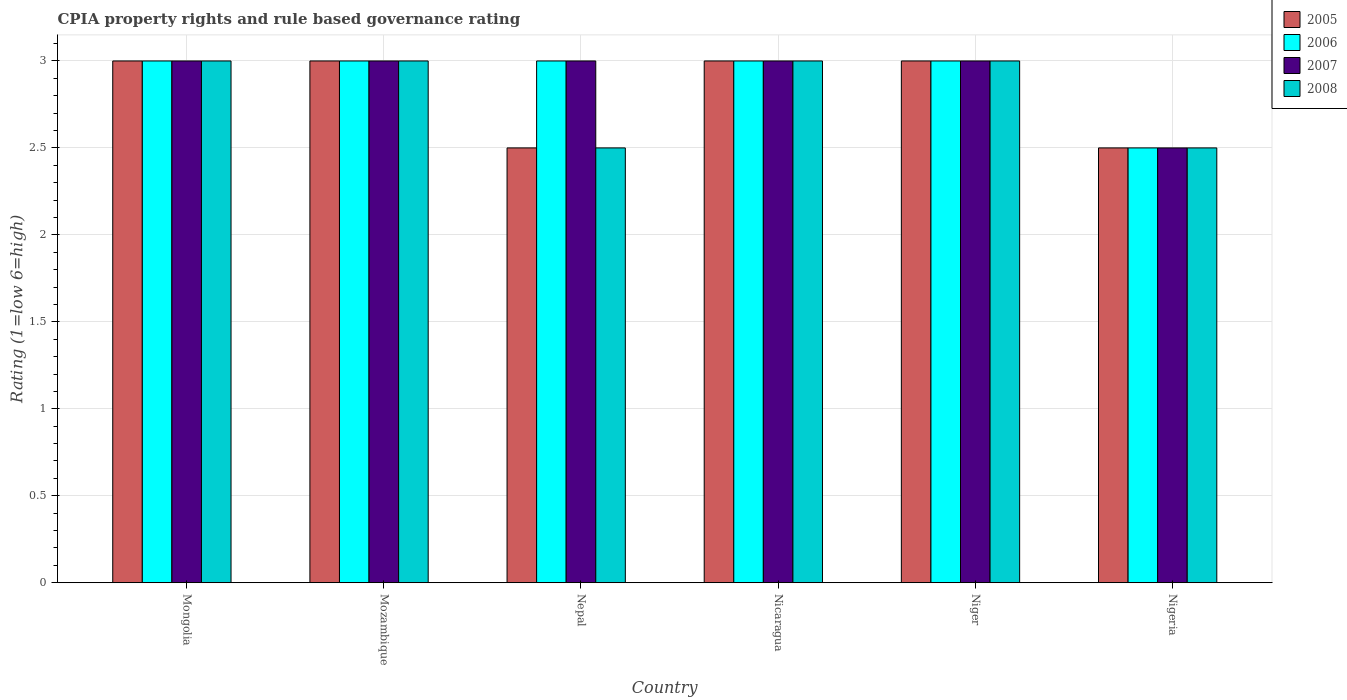How many groups of bars are there?
Your answer should be very brief. 6. Are the number of bars on each tick of the X-axis equal?
Make the answer very short. Yes. How many bars are there on the 1st tick from the left?
Make the answer very short. 4. How many bars are there on the 5th tick from the right?
Give a very brief answer. 4. What is the label of the 5th group of bars from the left?
Ensure brevity in your answer.  Niger. What is the CPIA rating in 2005 in Nepal?
Keep it short and to the point. 2.5. In which country was the CPIA rating in 2005 maximum?
Offer a terse response. Mongolia. In which country was the CPIA rating in 2007 minimum?
Provide a short and direct response. Nigeria. What is the difference between the CPIA rating in 2008 in Mongolia and that in Mozambique?
Give a very brief answer. 0. What is the average CPIA rating in 2006 per country?
Offer a terse response. 2.92. What is the difference between the CPIA rating of/in 2005 and CPIA rating of/in 2006 in Nicaragua?
Your response must be concise. 0. What is the ratio of the CPIA rating in 2006 in Mozambique to that in Nepal?
Offer a very short reply. 1. Is the difference between the CPIA rating in 2005 in Mozambique and Niger greater than the difference between the CPIA rating in 2006 in Mozambique and Niger?
Give a very brief answer. No. In how many countries, is the CPIA rating in 2005 greater than the average CPIA rating in 2005 taken over all countries?
Your response must be concise. 4. Is the sum of the CPIA rating in 2007 in Mongolia and Nigeria greater than the maximum CPIA rating in 2005 across all countries?
Offer a very short reply. Yes. Is it the case that in every country, the sum of the CPIA rating in 2005 and CPIA rating in 2006 is greater than the sum of CPIA rating in 2008 and CPIA rating in 2007?
Provide a succinct answer. No. What does the 1st bar from the left in Nigeria represents?
Offer a terse response. 2005. What does the 1st bar from the right in Mozambique represents?
Offer a very short reply. 2008. Is it the case that in every country, the sum of the CPIA rating in 2007 and CPIA rating in 2006 is greater than the CPIA rating in 2005?
Offer a very short reply. Yes. Does the graph contain any zero values?
Your answer should be very brief. No. Does the graph contain grids?
Keep it short and to the point. Yes. How many legend labels are there?
Provide a succinct answer. 4. How are the legend labels stacked?
Make the answer very short. Vertical. What is the title of the graph?
Your answer should be compact. CPIA property rights and rule based governance rating. Does "1993" appear as one of the legend labels in the graph?
Your response must be concise. No. What is the Rating (1=low 6=high) of 2005 in Mongolia?
Give a very brief answer. 3. What is the Rating (1=low 6=high) in 2008 in Mongolia?
Provide a succinct answer. 3. What is the Rating (1=low 6=high) of 2006 in Nepal?
Make the answer very short. 3. What is the Rating (1=low 6=high) in 2008 in Nepal?
Make the answer very short. 2.5. What is the Rating (1=low 6=high) of 2005 in Nicaragua?
Offer a very short reply. 3. What is the Rating (1=low 6=high) in 2006 in Nicaragua?
Provide a short and direct response. 3. What is the Rating (1=low 6=high) of 2007 in Nicaragua?
Your answer should be very brief. 3. What is the Rating (1=low 6=high) of 2005 in Niger?
Your response must be concise. 3. What is the Rating (1=low 6=high) in 2007 in Niger?
Provide a succinct answer. 3. What is the Rating (1=low 6=high) in 2005 in Nigeria?
Provide a succinct answer. 2.5. What is the Rating (1=low 6=high) of 2006 in Nigeria?
Your response must be concise. 2.5. What is the Rating (1=low 6=high) in 2007 in Nigeria?
Offer a terse response. 2.5. What is the Rating (1=low 6=high) of 2008 in Nigeria?
Your answer should be compact. 2.5. Across all countries, what is the maximum Rating (1=low 6=high) of 2005?
Your answer should be compact. 3. Across all countries, what is the minimum Rating (1=low 6=high) of 2005?
Make the answer very short. 2.5. What is the difference between the Rating (1=low 6=high) in 2005 in Mongolia and that in Mozambique?
Give a very brief answer. 0. What is the difference between the Rating (1=low 6=high) in 2006 in Mongolia and that in Mozambique?
Offer a very short reply. 0. What is the difference between the Rating (1=low 6=high) in 2007 in Mongolia and that in Mozambique?
Ensure brevity in your answer.  0. What is the difference between the Rating (1=low 6=high) of 2006 in Mongolia and that in Nepal?
Your answer should be compact. 0. What is the difference between the Rating (1=low 6=high) in 2007 in Mongolia and that in Nepal?
Offer a terse response. 0. What is the difference between the Rating (1=low 6=high) in 2008 in Mongolia and that in Nepal?
Your response must be concise. 0.5. What is the difference between the Rating (1=low 6=high) of 2005 in Mongolia and that in Nicaragua?
Provide a short and direct response. 0. What is the difference between the Rating (1=low 6=high) of 2006 in Mongolia and that in Nicaragua?
Your answer should be compact. 0. What is the difference between the Rating (1=low 6=high) of 2008 in Mongolia and that in Nicaragua?
Your answer should be compact. 0. What is the difference between the Rating (1=low 6=high) of 2006 in Mongolia and that in Niger?
Offer a very short reply. 0. What is the difference between the Rating (1=low 6=high) of 2007 in Mongolia and that in Niger?
Provide a short and direct response. 0. What is the difference between the Rating (1=low 6=high) in 2008 in Mongolia and that in Niger?
Keep it short and to the point. 0. What is the difference between the Rating (1=low 6=high) of 2006 in Mongolia and that in Nigeria?
Your answer should be very brief. 0.5. What is the difference between the Rating (1=low 6=high) in 2007 in Mongolia and that in Nigeria?
Make the answer very short. 0.5. What is the difference between the Rating (1=low 6=high) in 2008 in Mongolia and that in Nigeria?
Keep it short and to the point. 0.5. What is the difference between the Rating (1=low 6=high) in 2006 in Mozambique and that in Nepal?
Give a very brief answer. 0. What is the difference between the Rating (1=low 6=high) of 2007 in Mozambique and that in Nepal?
Offer a terse response. 0. What is the difference between the Rating (1=low 6=high) in 2008 in Mozambique and that in Nepal?
Ensure brevity in your answer.  0.5. What is the difference between the Rating (1=low 6=high) in 2007 in Mozambique and that in Nicaragua?
Offer a very short reply. 0. What is the difference between the Rating (1=low 6=high) of 2007 in Mozambique and that in Niger?
Provide a succinct answer. 0. What is the difference between the Rating (1=low 6=high) in 2006 in Mozambique and that in Nigeria?
Ensure brevity in your answer.  0.5. What is the difference between the Rating (1=low 6=high) in 2007 in Mozambique and that in Nigeria?
Offer a very short reply. 0.5. What is the difference between the Rating (1=low 6=high) in 2008 in Mozambique and that in Nigeria?
Give a very brief answer. 0.5. What is the difference between the Rating (1=low 6=high) in 2007 in Nepal and that in Nicaragua?
Keep it short and to the point. 0. What is the difference between the Rating (1=low 6=high) in 2006 in Nepal and that in Nigeria?
Give a very brief answer. 0.5. What is the difference between the Rating (1=low 6=high) of 2008 in Nepal and that in Nigeria?
Ensure brevity in your answer.  0. What is the difference between the Rating (1=low 6=high) of 2005 in Nicaragua and that in Nigeria?
Make the answer very short. 0.5. What is the difference between the Rating (1=low 6=high) in 2006 in Nicaragua and that in Nigeria?
Your answer should be very brief. 0.5. What is the difference between the Rating (1=low 6=high) of 2008 in Nicaragua and that in Nigeria?
Your answer should be compact. 0.5. What is the difference between the Rating (1=low 6=high) of 2005 in Niger and that in Nigeria?
Offer a very short reply. 0.5. What is the difference between the Rating (1=low 6=high) in 2006 in Niger and that in Nigeria?
Your answer should be very brief. 0.5. What is the difference between the Rating (1=low 6=high) in 2008 in Niger and that in Nigeria?
Offer a very short reply. 0.5. What is the difference between the Rating (1=low 6=high) in 2005 in Mongolia and the Rating (1=low 6=high) in 2006 in Mozambique?
Give a very brief answer. 0. What is the difference between the Rating (1=low 6=high) of 2005 in Mongolia and the Rating (1=low 6=high) of 2007 in Mozambique?
Provide a short and direct response. 0. What is the difference between the Rating (1=low 6=high) of 2005 in Mongolia and the Rating (1=low 6=high) of 2008 in Mozambique?
Your response must be concise. 0. What is the difference between the Rating (1=low 6=high) in 2006 in Mongolia and the Rating (1=low 6=high) in 2008 in Mozambique?
Your response must be concise. 0. What is the difference between the Rating (1=low 6=high) of 2007 in Mongolia and the Rating (1=low 6=high) of 2008 in Mozambique?
Your response must be concise. 0. What is the difference between the Rating (1=low 6=high) of 2005 in Mongolia and the Rating (1=low 6=high) of 2007 in Nepal?
Your response must be concise. 0. What is the difference between the Rating (1=low 6=high) of 2006 in Mongolia and the Rating (1=low 6=high) of 2008 in Nepal?
Provide a succinct answer. 0.5. What is the difference between the Rating (1=low 6=high) of 2005 in Mongolia and the Rating (1=low 6=high) of 2006 in Nicaragua?
Offer a very short reply. 0. What is the difference between the Rating (1=low 6=high) of 2005 in Mongolia and the Rating (1=low 6=high) of 2007 in Nicaragua?
Ensure brevity in your answer.  0. What is the difference between the Rating (1=low 6=high) of 2005 in Mongolia and the Rating (1=low 6=high) of 2008 in Nicaragua?
Your answer should be very brief. 0. What is the difference between the Rating (1=low 6=high) of 2006 in Mongolia and the Rating (1=low 6=high) of 2008 in Nicaragua?
Offer a very short reply. 0. What is the difference between the Rating (1=low 6=high) in 2005 in Mongolia and the Rating (1=low 6=high) in 2007 in Niger?
Give a very brief answer. 0. What is the difference between the Rating (1=low 6=high) of 2005 in Mongolia and the Rating (1=low 6=high) of 2008 in Niger?
Your answer should be compact. 0. What is the difference between the Rating (1=low 6=high) of 2006 in Mongolia and the Rating (1=low 6=high) of 2007 in Niger?
Give a very brief answer. 0. What is the difference between the Rating (1=low 6=high) in 2007 in Mongolia and the Rating (1=low 6=high) in 2008 in Niger?
Your answer should be very brief. 0. What is the difference between the Rating (1=low 6=high) of 2007 in Mozambique and the Rating (1=low 6=high) of 2008 in Nepal?
Make the answer very short. 0.5. What is the difference between the Rating (1=low 6=high) of 2005 in Mozambique and the Rating (1=low 6=high) of 2006 in Nicaragua?
Your answer should be compact. 0. What is the difference between the Rating (1=low 6=high) in 2005 in Mozambique and the Rating (1=low 6=high) in 2008 in Nicaragua?
Ensure brevity in your answer.  0. What is the difference between the Rating (1=low 6=high) of 2006 in Mozambique and the Rating (1=low 6=high) of 2007 in Nicaragua?
Keep it short and to the point. 0. What is the difference between the Rating (1=low 6=high) of 2007 in Mozambique and the Rating (1=low 6=high) of 2008 in Nicaragua?
Your answer should be compact. 0. What is the difference between the Rating (1=low 6=high) of 2006 in Mozambique and the Rating (1=low 6=high) of 2007 in Niger?
Give a very brief answer. 0. What is the difference between the Rating (1=low 6=high) in 2006 in Mozambique and the Rating (1=low 6=high) in 2008 in Niger?
Ensure brevity in your answer.  0. What is the difference between the Rating (1=low 6=high) of 2005 in Mozambique and the Rating (1=low 6=high) of 2007 in Nigeria?
Your response must be concise. 0.5. What is the difference between the Rating (1=low 6=high) in 2005 in Nepal and the Rating (1=low 6=high) in 2006 in Nicaragua?
Ensure brevity in your answer.  -0.5. What is the difference between the Rating (1=low 6=high) of 2005 in Nepal and the Rating (1=low 6=high) of 2007 in Nicaragua?
Ensure brevity in your answer.  -0.5. What is the difference between the Rating (1=low 6=high) in 2005 in Nepal and the Rating (1=low 6=high) in 2006 in Niger?
Your answer should be very brief. -0.5. What is the difference between the Rating (1=low 6=high) in 2006 in Nepal and the Rating (1=low 6=high) in 2007 in Niger?
Offer a terse response. 0. What is the difference between the Rating (1=low 6=high) in 2007 in Nepal and the Rating (1=low 6=high) in 2008 in Niger?
Give a very brief answer. 0. What is the difference between the Rating (1=low 6=high) of 2005 in Nepal and the Rating (1=low 6=high) of 2006 in Nigeria?
Give a very brief answer. 0. What is the difference between the Rating (1=low 6=high) of 2006 in Nepal and the Rating (1=low 6=high) of 2007 in Nigeria?
Make the answer very short. 0.5. What is the difference between the Rating (1=low 6=high) of 2007 in Nepal and the Rating (1=low 6=high) of 2008 in Nigeria?
Make the answer very short. 0.5. What is the difference between the Rating (1=low 6=high) of 2005 in Nicaragua and the Rating (1=low 6=high) of 2007 in Niger?
Your response must be concise. 0. What is the difference between the Rating (1=low 6=high) in 2006 in Nicaragua and the Rating (1=low 6=high) in 2008 in Niger?
Your answer should be compact. 0. What is the difference between the Rating (1=low 6=high) of 2005 in Nicaragua and the Rating (1=low 6=high) of 2007 in Nigeria?
Offer a terse response. 0.5. What is the difference between the Rating (1=low 6=high) of 2006 in Nicaragua and the Rating (1=low 6=high) of 2007 in Nigeria?
Offer a terse response. 0.5. What is the difference between the Rating (1=low 6=high) of 2007 in Nicaragua and the Rating (1=low 6=high) of 2008 in Nigeria?
Provide a short and direct response. 0.5. What is the difference between the Rating (1=low 6=high) in 2005 in Niger and the Rating (1=low 6=high) in 2006 in Nigeria?
Make the answer very short. 0.5. What is the difference between the Rating (1=low 6=high) of 2006 in Niger and the Rating (1=low 6=high) of 2007 in Nigeria?
Provide a short and direct response. 0.5. What is the difference between the Rating (1=low 6=high) in 2007 in Niger and the Rating (1=low 6=high) in 2008 in Nigeria?
Your response must be concise. 0.5. What is the average Rating (1=low 6=high) in 2005 per country?
Your response must be concise. 2.83. What is the average Rating (1=low 6=high) of 2006 per country?
Your answer should be compact. 2.92. What is the average Rating (1=low 6=high) of 2007 per country?
Your answer should be compact. 2.92. What is the average Rating (1=low 6=high) of 2008 per country?
Ensure brevity in your answer.  2.83. What is the difference between the Rating (1=low 6=high) in 2005 and Rating (1=low 6=high) in 2008 in Mongolia?
Provide a short and direct response. 0. What is the difference between the Rating (1=low 6=high) in 2006 and Rating (1=low 6=high) in 2008 in Mongolia?
Your response must be concise. 0. What is the difference between the Rating (1=low 6=high) of 2007 and Rating (1=low 6=high) of 2008 in Mongolia?
Offer a terse response. 0. What is the difference between the Rating (1=low 6=high) in 2005 and Rating (1=low 6=high) in 2007 in Mozambique?
Give a very brief answer. 0. What is the difference between the Rating (1=low 6=high) in 2005 and Rating (1=low 6=high) in 2008 in Mozambique?
Keep it short and to the point. 0. What is the difference between the Rating (1=low 6=high) of 2007 and Rating (1=low 6=high) of 2008 in Mozambique?
Provide a succinct answer. 0. What is the difference between the Rating (1=low 6=high) in 2005 and Rating (1=low 6=high) in 2006 in Nepal?
Make the answer very short. -0.5. What is the difference between the Rating (1=low 6=high) in 2005 and Rating (1=low 6=high) in 2007 in Nepal?
Make the answer very short. -0.5. What is the difference between the Rating (1=low 6=high) in 2005 and Rating (1=low 6=high) in 2007 in Nicaragua?
Keep it short and to the point. 0. What is the difference between the Rating (1=low 6=high) in 2005 and Rating (1=low 6=high) in 2008 in Nicaragua?
Your answer should be very brief. 0. What is the difference between the Rating (1=low 6=high) in 2007 and Rating (1=low 6=high) in 2008 in Nicaragua?
Keep it short and to the point. 0. What is the difference between the Rating (1=low 6=high) of 2005 and Rating (1=low 6=high) of 2006 in Niger?
Provide a succinct answer. 0. What is the difference between the Rating (1=low 6=high) in 2005 and Rating (1=low 6=high) in 2007 in Niger?
Provide a succinct answer. 0. What is the difference between the Rating (1=low 6=high) in 2005 and Rating (1=low 6=high) in 2008 in Niger?
Your answer should be very brief. 0. What is the difference between the Rating (1=low 6=high) in 2005 and Rating (1=low 6=high) in 2006 in Nigeria?
Offer a very short reply. 0. What is the difference between the Rating (1=low 6=high) in 2005 and Rating (1=low 6=high) in 2007 in Nigeria?
Offer a terse response. 0. What is the difference between the Rating (1=low 6=high) in 2005 and Rating (1=low 6=high) in 2008 in Nigeria?
Keep it short and to the point. 0. What is the difference between the Rating (1=low 6=high) in 2006 and Rating (1=low 6=high) in 2007 in Nigeria?
Offer a terse response. 0. What is the difference between the Rating (1=low 6=high) in 2007 and Rating (1=low 6=high) in 2008 in Nigeria?
Your response must be concise. 0. What is the ratio of the Rating (1=low 6=high) of 2006 in Mongolia to that in Mozambique?
Provide a short and direct response. 1. What is the ratio of the Rating (1=low 6=high) of 2008 in Mongolia to that in Mozambique?
Your answer should be compact. 1. What is the ratio of the Rating (1=low 6=high) of 2005 in Mongolia to that in Nepal?
Make the answer very short. 1.2. What is the ratio of the Rating (1=low 6=high) of 2006 in Mongolia to that in Nepal?
Keep it short and to the point. 1. What is the ratio of the Rating (1=low 6=high) of 2007 in Mongolia to that in Nepal?
Provide a succinct answer. 1. What is the ratio of the Rating (1=low 6=high) in 2008 in Mongolia to that in Nepal?
Your answer should be very brief. 1.2. What is the ratio of the Rating (1=low 6=high) of 2006 in Mongolia to that in Nicaragua?
Provide a short and direct response. 1. What is the ratio of the Rating (1=low 6=high) in 2008 in Mongolia to that in Nicaragua?
Provide a succinct answer. 1. What is the ratio of the Rating (1=low 6=high) of 2006 in Mongolia to that in Niger?
Your response must be concise. 1. What is the ratio of the Rating (1=low 6=high) in 2007 in Mongolia to that in Niger?
Your answer should be very brief. 1. What is the ratio of the Rating (1=low 6=high) of 2005 in Mongolia to that in Nigeria?
Your answer should be compact. 1.2. What is the ratio of the Rating (1=low 6=high) of 2006 in Mongolia to that in Nigeria?
Your answer should be very brief. 1.2. What is the ratio of the Rating (1=low 6=high) of 2008 in Mongolia to that in Nigeria?
Make the answer very short. 1.2. What is the ratio of the Rating (1=low 6=high) of 2005 in Mozambique to that in Nepal?
Give a very brief answer. 1.2. What is the ratio of the Rating (1=low 6=high) of 2006 in Mozambique to that in Nepal?
Provide a succinct answer. 1. What is the ratio of the Rating (1=low 6=high) of 2008 in Mozambique to that in Nepal?
Your answer should be very brief. 1.2. What is the ratio of the Rating (1=low 6=high) of 2006 in Mozambique to that in Nicaragua?
Provide a succinct answer. 1. What is the ratio of the Rating (1=low 6=high) of 2007 in Mozambique to that in Nicaragua?
Offer a terse response. 1. What is the ratio of the Rating (1=low 6=high) of 2005 in Mozambique to that in Niger?
Provide a succinct answer. 1. What is the ratio of the Rating (1=low 6=high) in 2006 in Mozambique to that in Niger?
Your answer should be compact. 1. What is the ratio of the Rating (1=low 6=high) in 2008 in Mozambique to that in Niger?
Offer a very short reply. 1. What is the ratio of the Rating (1=low 6=high) in 2005 in Mozambique to that in Nigeria?
Your answer should be very brief. 1.2. What is the ratio of the Rating (1=low 6=high) in 2006 in Mozambique to that in Nigeria?
Make the answer very short. 1.2. What is the ratio of the Rating (1=low 6=high) in 2005 in Nepal to that in Nicaragua?
Provide a short and direct response. 0.83. What is the ratio of the Rating (1=low 6=high) of 2006 in Nepal to that in Nicaragua?
Your answer should be compact. 1. What is the ratio of the Rating (1=low 6=high) in 2007 in Nepal to that in Nicaragua?
Make the answer very short. 1. What is the ratio of the Rating (1=low 6=high) in 2008 in Nepal to that in Nicaragua?
Offer a very short reply. 0.83. What is the ratio of the Rating (1=low 6=high) of 2005 in Nepal to that in Nigeria?
Provide a succinct answer. 1. What is the ratio of the Rating (1=low 6=high) in 2007 in Nepal to that in Nigeria?
Ensure brevity in your answer.  1.2. What is the ratio of the Rating (1=low 6=high) of 2005 in Nicaragua to that in Niger?
Give a very brief answer. 1. What is the ratio of the Rating (1=low 6=high) in 2006 in Nicaragua to that in Nigeria?
Keep it short and to the point. 1.2. What is the ratio of the Rating (1=low 6=high) of 2006 in Niger to that in Nigeria?
Offer a very short reply. 1.2. What is the difference between the highest and the second highest Rating (1=low 6=high) in 2005?
Provide a succinct answer. 0. What is the difference between the highest and the second highest Rating (1=low 6=high) of 2006?
Your answer should be compact. 0. What is the difference between the highest and the second highest Rating (1=low 6=high) in 2007?
Your answer should be very brief. 0. What is the difference between the highest and the lowest Rating (1=low 6=high) of 2006?
Provide a succinct answer. 0.5. What is the difference between the highest and the lowest Rating (1=low 6=high) in 2007?
Make the answer very short. 0.5. 